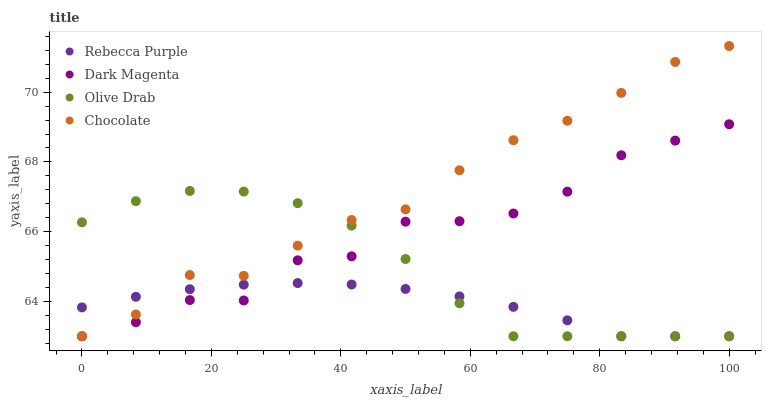Does Rebecca Purple have the minimum area under the curve?
Answer yes or no. Yes. Does Chocolate have the maximum area under the curve?
Answer yes or no. Yes. Does Olive Drab have the minimum area under the curve?
Answer yes or no. No. Does Olive Drab have the maximum area under the curve?
Answer yes or no. No. Is Rebecca Purple the smoothest?
Answer yes or no. Yes. Is Dark Magenta the roughest?
Answer yes or no. Yes. Is Olive Drab the smoothest?
Answer yes or no. No. Is Olive Drab the roughest?
Answer yes or no. No. Does Chocolate have the lowest value?
Answer yes or no. Yes. Does Chocolate have the highest value?
Answer yes or no. Yes. Does Olive Drab have the highest value?
Answer yes or no. No. Does Olive Drab intersect Dark Magenta?
Answer yes or no. Yes. Is Olive Drab less than Dark Magenta?
Answer yes or no. No. Is Olive Drab greater than Dark Magenta?
Answer yes or no. No. 